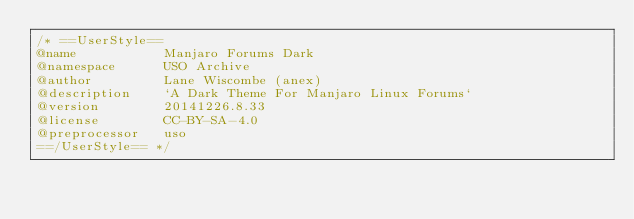Convert code to text. <code><loc_0><loc_0><loc_500><loc_500><_CSS_>/* ==UserStyle==
@name           Manjaro Forums Dark
@namespace      USO Archive
@author         Lane Wiscombe (anex)
@description    `A Dark Theme For Manjaro Linux Forums`
@version        20141226.8.33
@license        CC-BY-SA-4.0
@preprocessor   uso
==/UserStyle== */</code> 